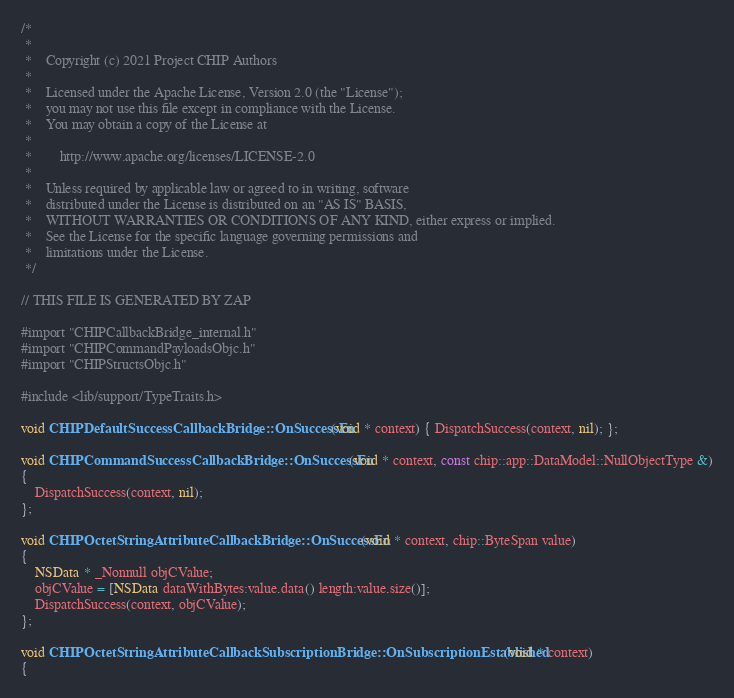<code> <loc_0><loc_0><loc_500><loc_500><_ObjectiveC_>/*
 *
 *    Copyright (c) 2021 Project CHIP Authors
 *
 *    Licensed under the Apache License, Version 2.0 (the "License");
 *    you may not use this file except in compliance with the License.
 *    You may obtain a copy of the License at
 *
 *        http://www.apache.org/licenses/LICENSE-2.0
 *
 *    Unless required by applicable law or agreed to in writing, software
 *    distributed under the License is distributed on an "AS IS" BASIS,
 *    WITHOUT WARRANTIES OR CONDITIONS OF ANY KIND, either express or implied.
 *    See the License for the specific language governing permissions and
 *    limitations under the License.
 */

// THIS FILE IS GENERATED BY ZAP

#import "CHIPCallbackBridge_internal.h"
#import "CHIPCommandPayloadsObjc.h"
#import "CHIPStructsObjc.h"

#include <lib/support/TypeTraits.h>

void CHIPDefaultSuccessCallbackBridge::OnSuccessFn(void * context) { DispatchSuccess(context, nil); };

void CHIPCommandSuccessCallbackBridge::OnSuccessFn(void * context, const chip::app::DataModel::NullObjectType &)
{
    DispatchSuccess(context, nil);
};

void CHIPOctetStringAttributeCallbackBridge::OnSuccessFn(void * context, chip::ByteSpan value)
{
    NSData * _Nonnull objCValue;
    objCValue = [NSData dataWithBytes:value.data() length:value.size()];
    DispatchSuccess(context, objCValue);
};

void CHIPOctetStringAttributeCallbackSubscriptionBridge::OnSubscriptionEstablished(void * context)
{</code> 